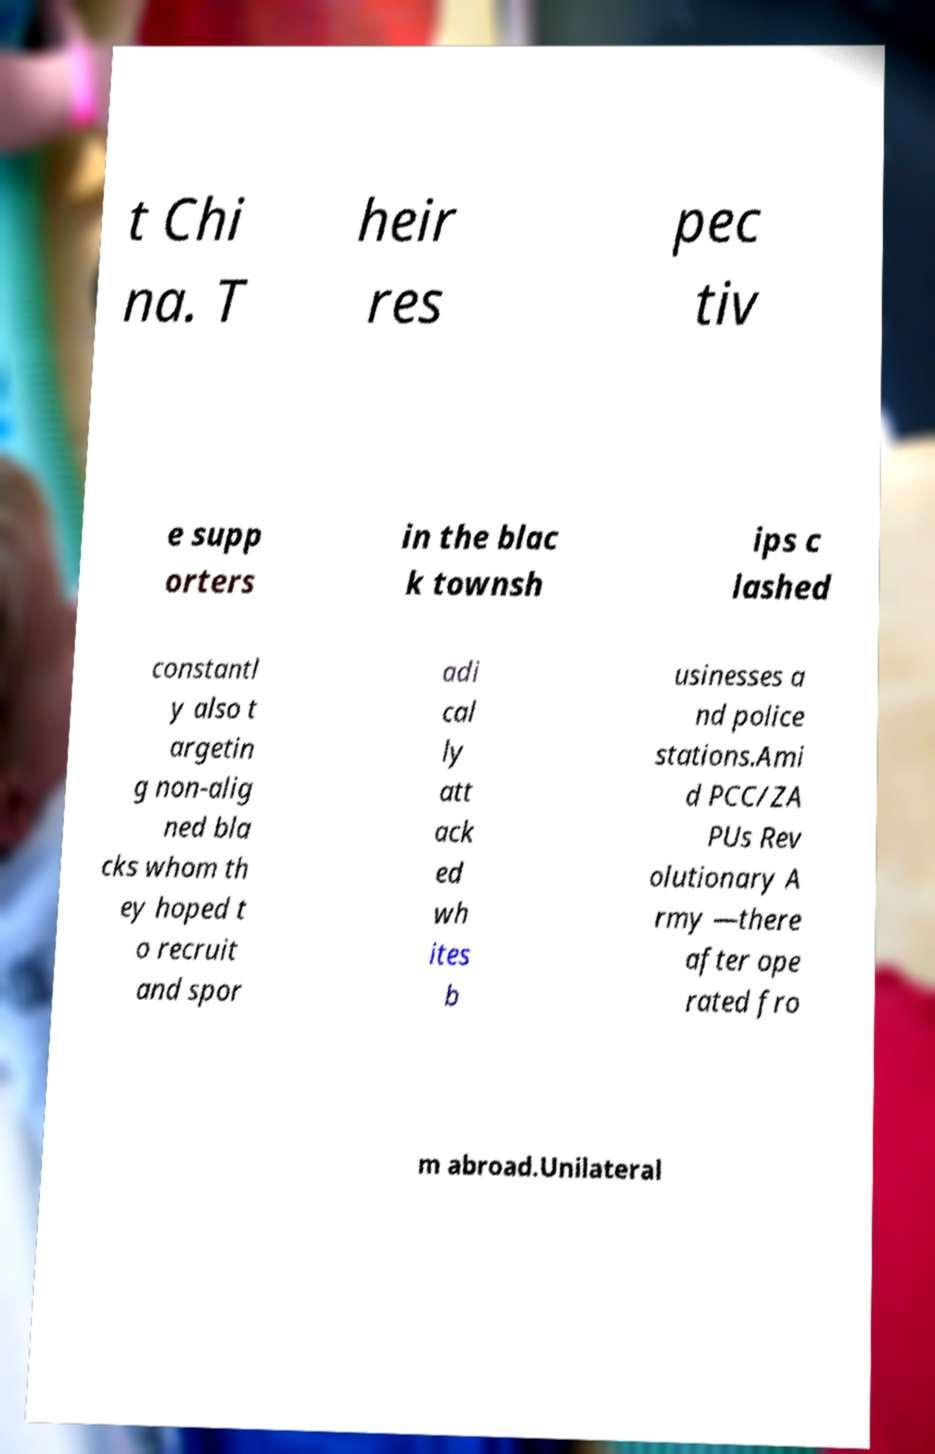Could you assist in decoding the text presented in this image and type it out clearly? t Chi na. T heir res pec tiv e supp orters in the blac k townsh ips c lashed constantl y also t argetin g non-alig ned bla cks whom th ey hoped t o recruit and spor adi cal ly att ack ed wh ites b usinesses a nd police stations.Ami d PCC/ZA PUs Rev olutionary A rmy —there after ope rated fro m abroad.Unilateral 